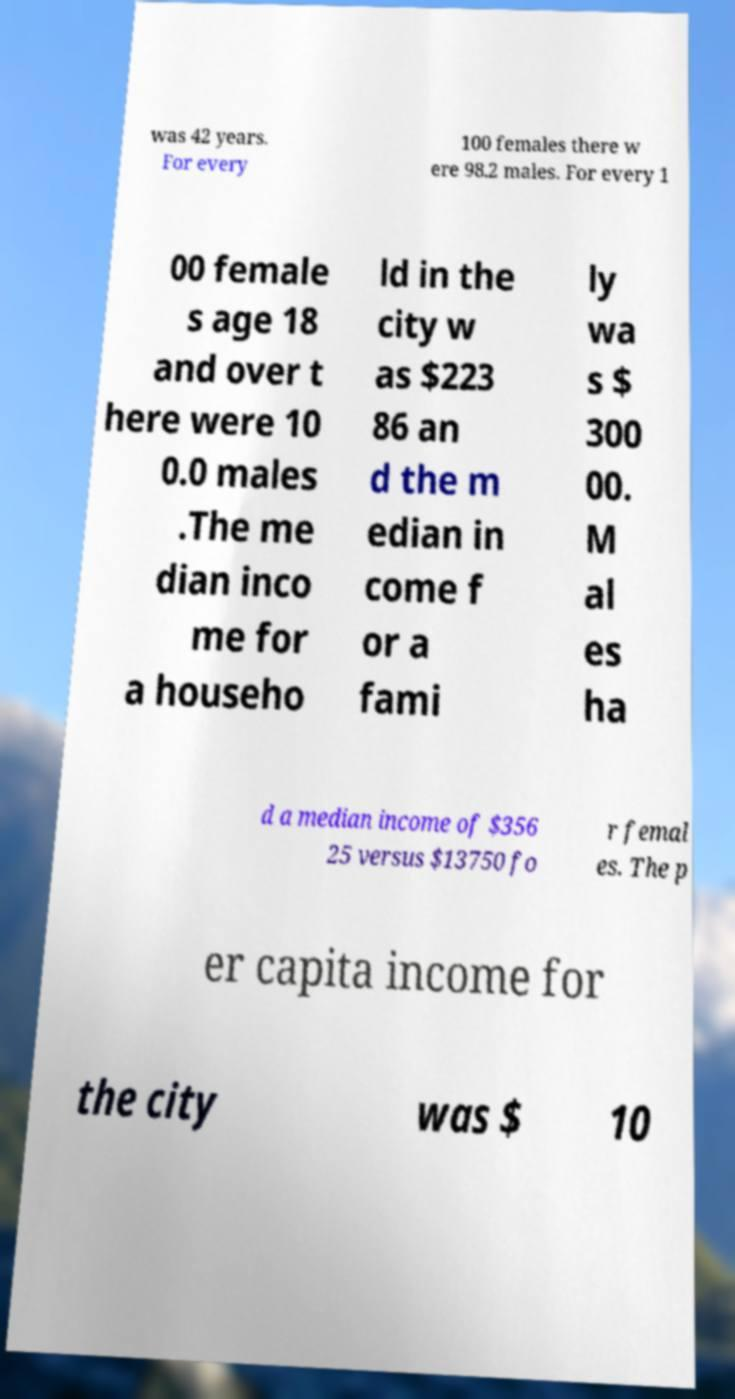Please identify and transcribe the text found in this image. was 42 years. For every 100 females there w ere 98.2 males. For every 1 00 female s age 18 and over t here were 10 0.0 males .The me dian inco me for a househo ld in the city w as $223 86 an d the m edian in come f or a fami ly wa s $ 300 00. M al es ha d a median income of $356 25 versus $13750 fo r femal es. The p er capita income for the city was $ 10 